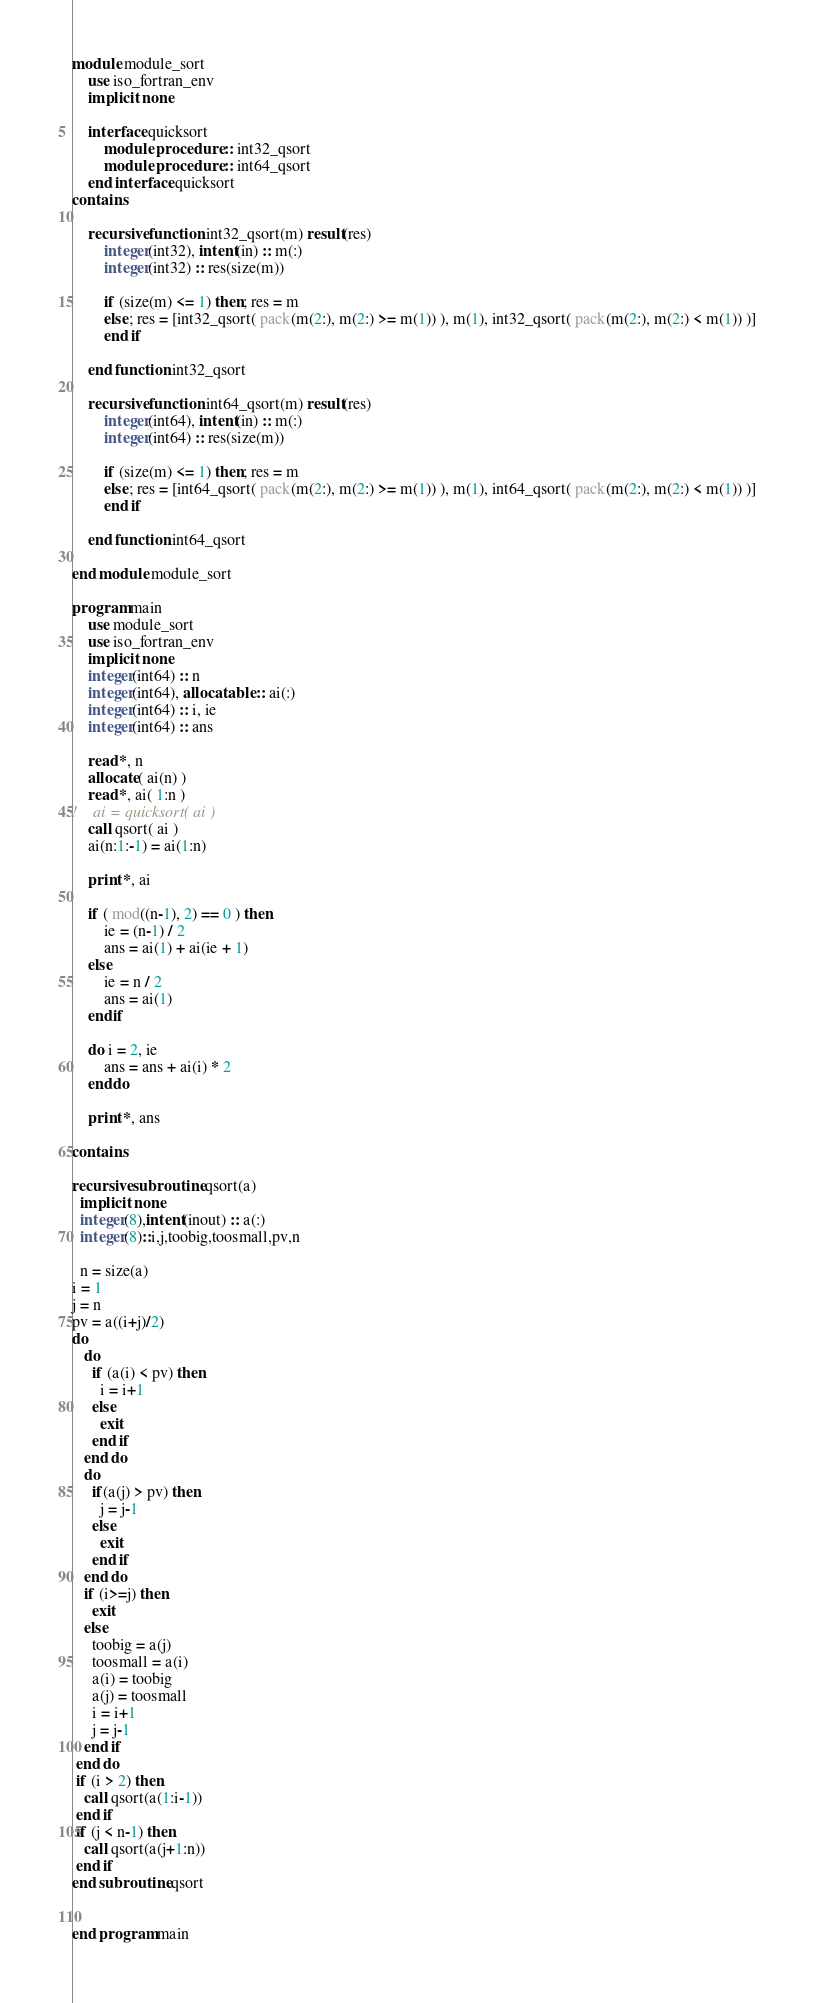<code> <loc_0><loc_0><loc_500><loc_500><_FORTRAN_>module module_sort
    use iso_fortran_env
    implicit none

    interface quicksort
        module procedure :: int32_qsort
        module procedure :: int64_qsort
    end interface quicksort
contains

    recursive function int32_qsort(m) result(res)
        integer(int32), intent(in) :: m(:)
        integer(int32) :: res(size(m)) 

        if (size(m) <= 1) then; res = m
        else; res = [int32_qsort( pack(m(2:), m(2:) >= m(1)) ), m(1), int32_qsort( pack(m(2:), m(2:) < m(1)) )]
        end if

    end function int32_qsort

    recursive function int64_qsort(m) result(res)
        integer(int64), intent(in) :: m(:)
        integer(int64) :: res(size(m)) 

        if (size(m) <= 1) then; res = m
        else; res = [int64_qsort( pack(m(2:), m(2:) >= m(1)) ), m(1), int64_qsort( pack(m(2:), m(2:) < m(1)) )]
        end if

    end function int64_qsort

end module module_sort

program main
    use module_sort
    use iso_fortran_env
    implicit none
    integer(int64) :: n
    integer(int64), allocatable :: ai(:)
    integer(int64) :: i, ie
    integer(int64) :: ans

    read *, n
    allocate( ai(n) )
    read *, ai( 1:n )
!    ai = quicksort( ai )
    call qsort( ai )
    ai(n:1:-1) = ai(1:n)

    print *, ai

    if ( mod((n-1), 2) == 0 ) then
        ie = (n-1) / 2
        ans = ai(1) + ai(ie + 1)
    else
        ie = n / 2
        ans = ai(1)
    endif

    do i = 2, ie
        ans = ans + ai(i) * 2
    enddo

    print *, ans

contains

recursive subroutine qsort(a)
  implicit none
  integer(8),intent(inout) :: a(:)
  integer(8)::i,j,toobig,toosmall,pv,n

  n = size(a)
i = 1
j = n
pv = a((i+j)/2)
do
   do
     if (a(i) < pv) then
       i = i+1
     else
       exit
     end if
   end do
   do
     if(a(j) > pv) then
       j = j-1
     else
       exit
     end if
   end do
   if (i>=j) then
     exit
   else
     toobig = a(j)
     toosmall = a(i)
     a(i) = toobig
     a(j) = toosmall
     i = i+1
     j = j-1
   end if
 end do
 if (i > 2) then
   call qsort(a(1:i-1))
 end if
 if (j < n-1) then
   call qsort(a(j+1:n))
 end if
end subroutine qsort


end program main</code> 